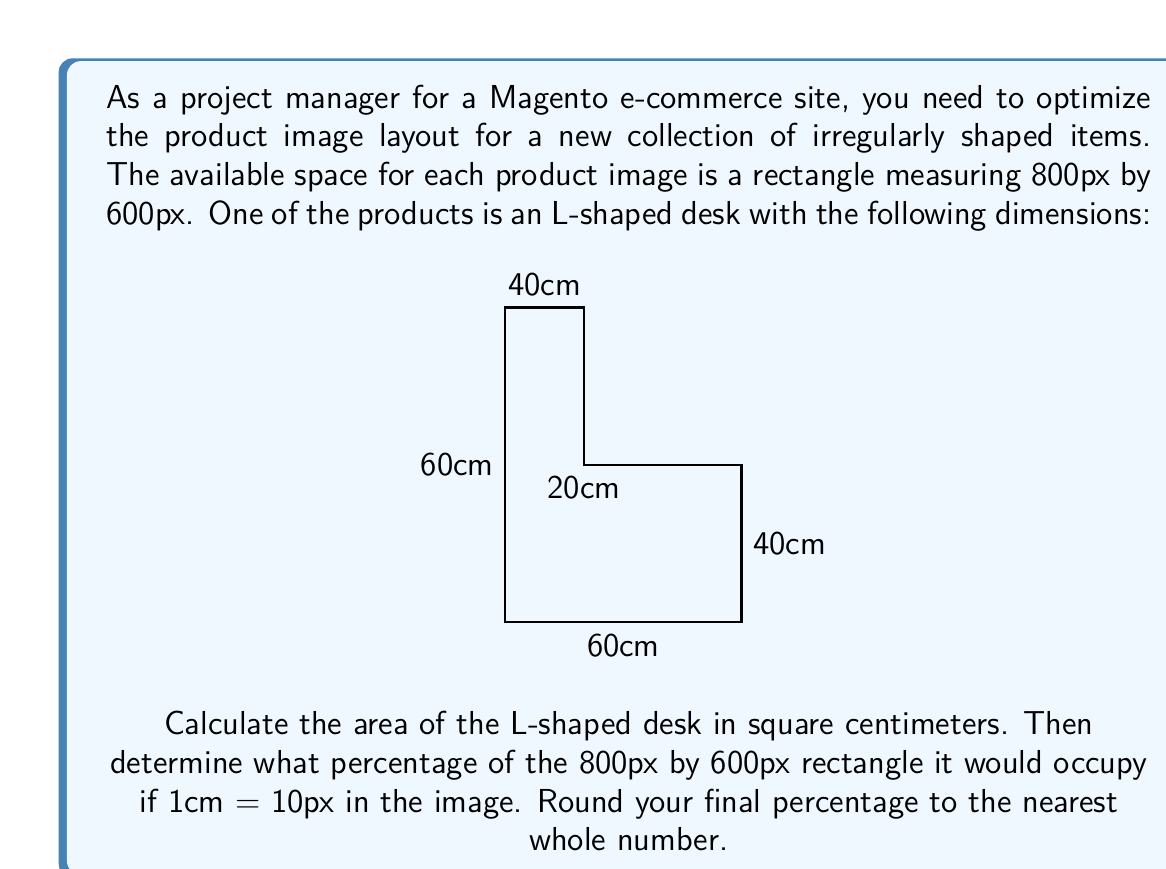Can you solve this math problem? Let's approach this problem step-by-step:

1) First, we need to calculate the area of the L-shaped desk. We can do this by dividing the shape into two rectangles and summing their areas.

2) The first rectangle:
   Width = 60 cm
   Height = 40 cm
   Area1 = $60 \times 40 = 2400$ cm²

3) The second rectangle:
   Width = 20 cm
   Height = 40 cm
   Area2 = $20 \times 40 = 800$ cm²

4) Total area of the L-shaped desk:
   $$A_{total} = 2400 + 800 = 3200$$ cm²

5) Now, we need to convert the image dimensions from pixels to centimeters:
   800px ÷ 10 = 80 cm (width)
   600px ÷ 10 = 60 cm (height)

6) Area of the image rectangle in cm²:
   $$A_{image} = 80 \times 60 = 4800$$ cm²

7) To calculate the percentage of the image area that the desk occupies:
   $$\text{Percentage} = \frac{A_{total}}{A_{image}} \times 100\%$$
   $$= \frac{3200}{4800} \times 100\% \approx 66.67\%$$

8) Rounding to the nearest whole number: 67%
Answer: 67% 